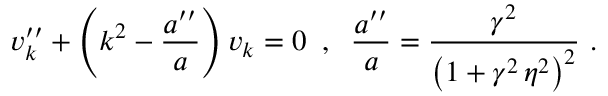<formula> <loc_0><loc_0><loc_500><loc_500>v _ { k } ^ { \prime \prime } + \left ( k ^ { 2 } - \frac { a ^ { \prime \prime } } { a } \right ) v _ { k } = 0 \, , \, \frac { a ^ { \prime \prime } } { a } = \frac { \gamma ^ { 2 } } { \left ( 1 + \gamma ^ { 2 } \, \eta ^ { 2 } \right ) ^ { 2 } } \, .</formula> 